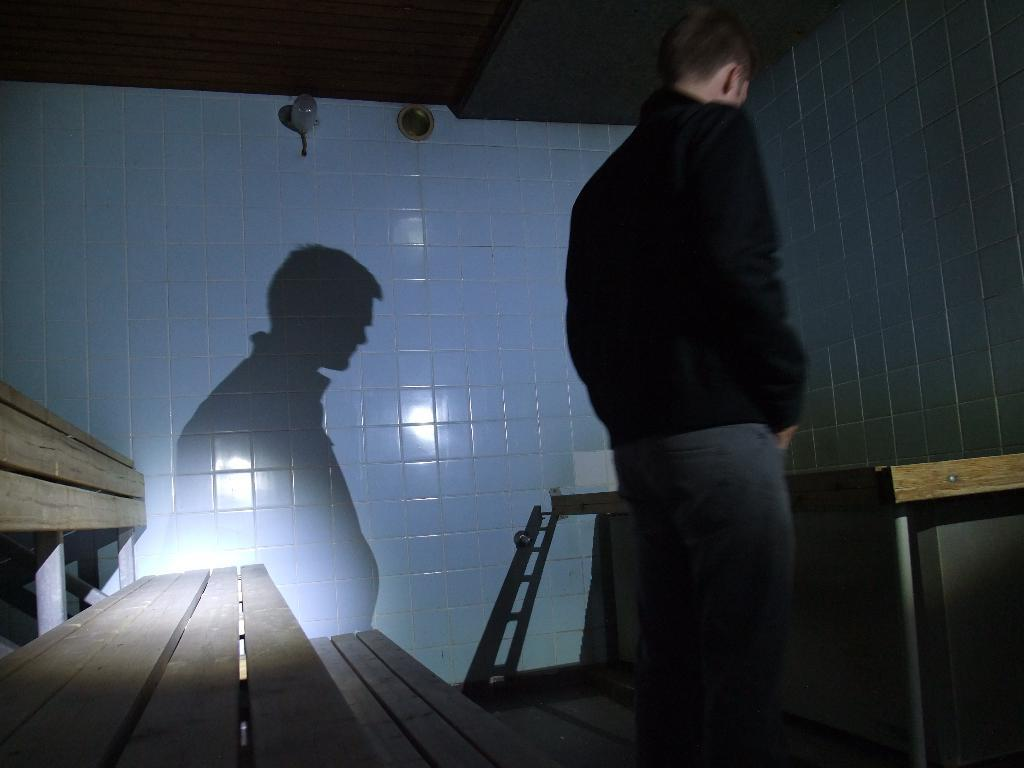What is the main subject of the image? There is a man standing in the image. What is in front of the man? There is a table in front of the man. Can you describe any other elements in the image? The man's shadow is visible on the wall, and there is a bench at the back of the man. What type of representative is sitting on the coast in the image? There is no representative or coast present in the image; it features a man standing with a table, a shadow, and a bench. How does the man's stomach appear in the image? The image does not show the man's stomach, so it cannot be described. 